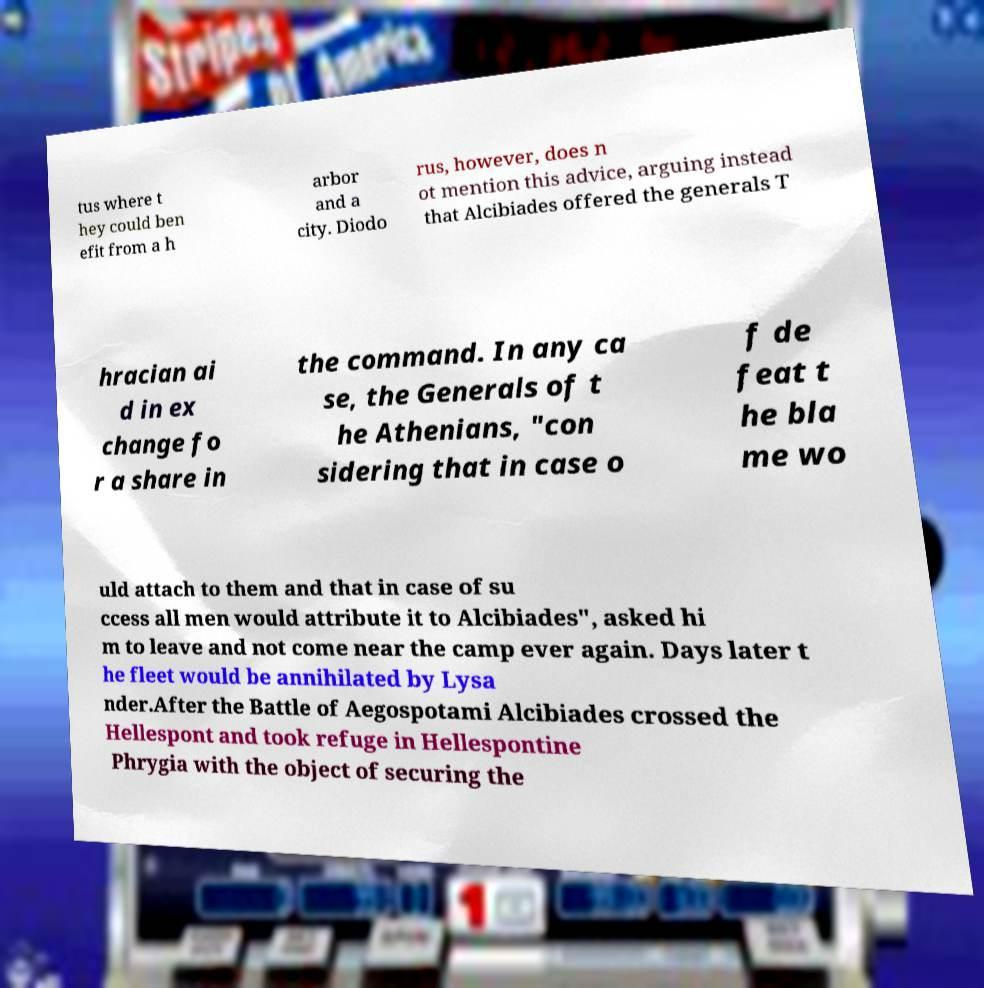Can you accurately transcribe the text from the provided image for me? tus where t hey could ben efit from a h arbor and a city. Diodo rus, however, does n ot mention this advice, arguing instead that Alcibiades offered the generals T hracian ai d in ex change fo r a share in the command. In any ca se, the Generals of t he Athenians, "con sidering that in case o f de feat t he bla me wo uld attach to them and that in case of su ccess all men would attribute it to Alcibiades", asked hi m to leave and not come near the camp ever again. Days later t he fleet would be annihilated by Lysa nder.After the Battle of Aegospotami Alcibiades crossed the Hellespont and took refuge in Hellespontine Phrygia with the object of securing the 